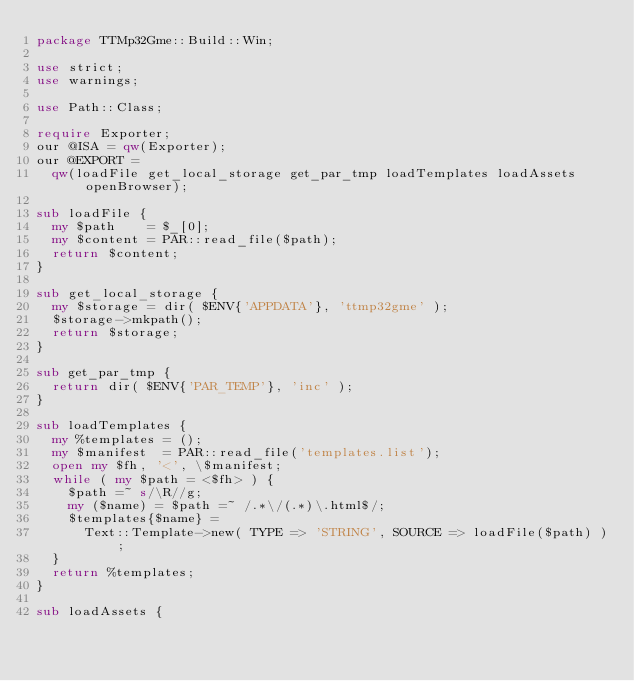<code> <loc_0><loc_0><loc_500><loc_500><_Perl_>package TTMp32Gme::Build::Win;

use strict;
use warnings;

use Path::Class;

require Exporter;
our @ISA = qw(Exporter);
our @EXPORT =
	qw(loadFile get_local_storage get_par_tmp loadTemplates loadAssets openBrowser);

sub loadFile {
	my $path    = $_[0];
	my $content = PAR::read_file($path);
	return $content;
}

sub get_local_storage {
	my $storage = dir( $ENV{'APPDATA'}, 'ttmp32gme' );
	$storage->mkpath();
	return $storage;
}

sub get_par_tmp {
	return dir( $ENV{'PAR_TEMP'}, 'inc' );
}

sub loadTemplates {
	my %templates = ();
	my $manifest  = PAR::read_file('templates.list');
	open my $fh, '<', \$manifest;
	while ( my $path = <$fh> ) {
		$path =~ s/\R//g;
		my ($name) = $path =~ /.*\/(.*)\.html$/;
		$templates{$name} =
			Text::Template->new( TYPE => 'STRING', SOURCE => loadFile($path) );
	}
	return %templates;
}

sub loadAssets {</code> 